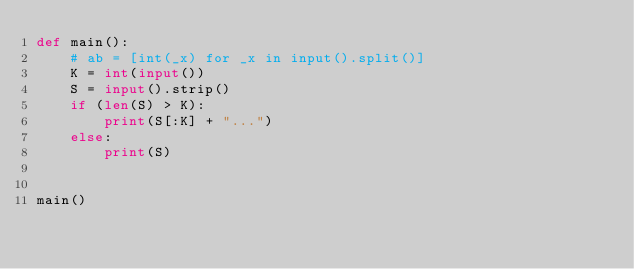Convert code to text. <code><loc_0><loc_0><loc_500><loc_500><_Python_>def main():
    # ab = [int(_x) for _x in input().split()]
    K = int(input())
    S = input().strip()
    if (len(S) > K):
        print(S[:K] + "...")
    else:
        print(S)


main()
</code> 